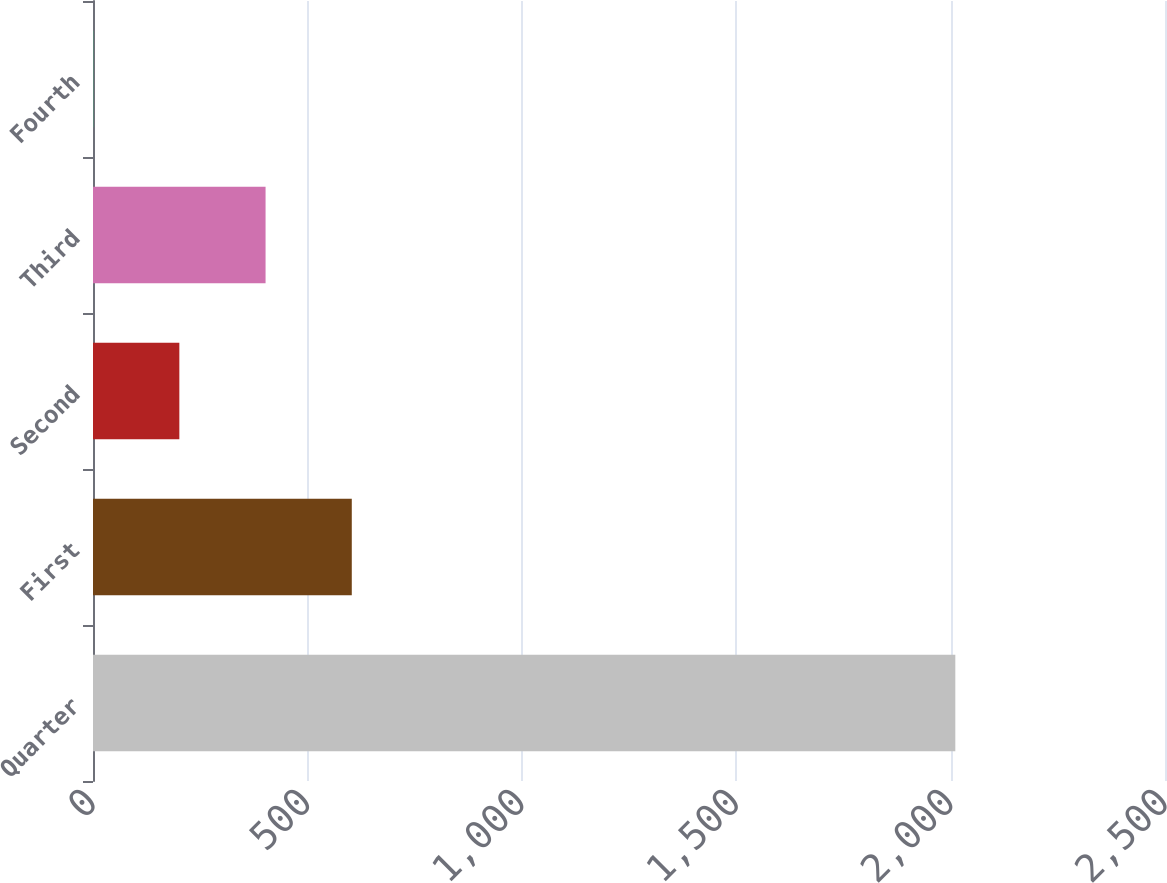Convert chart. <chart><loc_0><loc_0><loc_500><loc_500><bar_chart><fcel>Quarter<fcel>First<fcel>Second<fcel>Third<fcel>Fourth<nl><fcel>2011<fcel>603.51<fcel>201.37<fcel>402.44<fcel>0.3<nl></chart> 